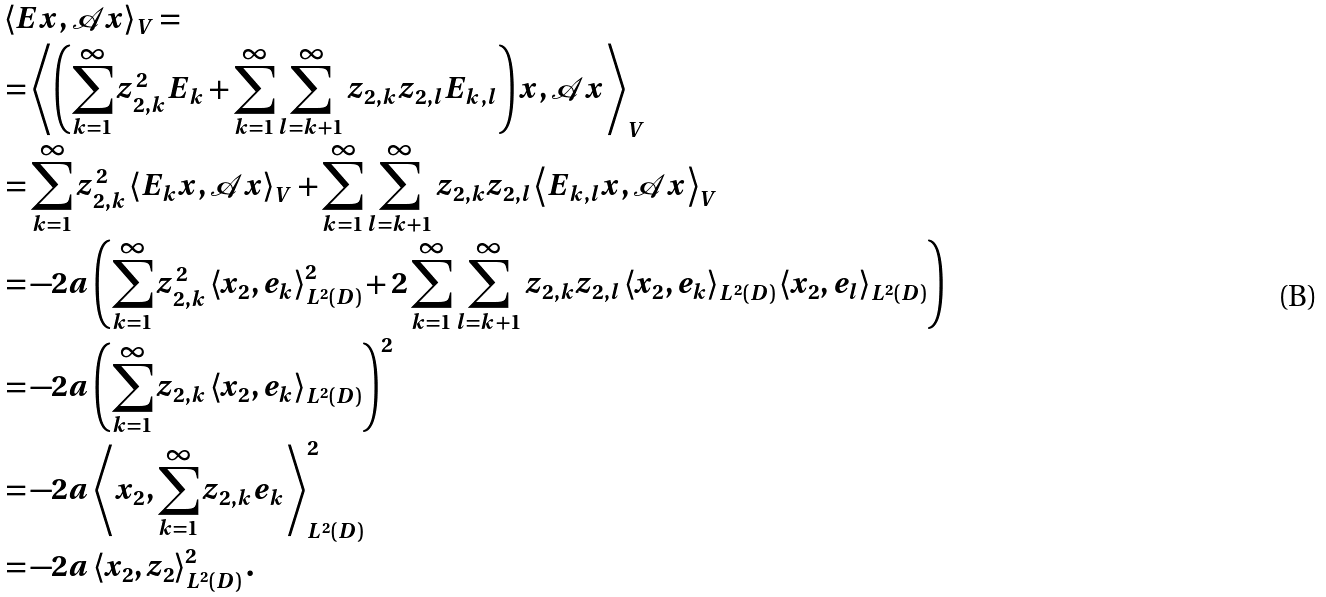<formula> <loc_0><loc_0><loc_500><loc_500>& \left \langle E x , \mathcal { A } x \right \rangle _ { V } = \\ & = \left \langle \left ( \sum _ { k = 1 } ^ { \infty } z _ { 2 , k } ^ { 2 } E _ { k } + \sum _ { k = 1 } ^ { \infty } \sum _ { l = k + 1 } ^ { \infty } z _ { 2 , k } z _ { 2 , l } E _ { k , l } \right ) x , \mathcal { A } x \right \rangle _ { V } \\ & = \sum _ { k = 1 } ^ { \infty } z _ { 2 , k } ^ { 2 } \left \langle E _ { k } x , \mathcal { A } x \right \rangle _ { V } + \sum _ { k = 1 } ^ { \infty } \sum _ { l = k + 1 } ^ { \infty } z _ { 2 , k } z _ { 2 , l } \left \langle E _ { k , l } x , \mathcal { A } x \right \rangle _ { V } \\ & = - 2 a \left ( \sum _ { k = 1 } ^ { \infty } z _ { 2 , k } ^ { 2 } \left \langle x _ { 2 } , e _ { k } \right \rangle _ { L ^ { 2 } ( D ) } ^ { 2 } + 2 \sum _ { k = 1 } ^ { \infty } \sum _ { l = k + 1 } ^ { \infty } z _ { 2 , k } z _ { 2 , l } \left \langle x _ { 2 } , e _ { k } \right \rangle _ { L ^ { 2 } ( D ) } \left \langle x _ { 2 } , e _ { l } \right \rangle _ { L ^ { 2 } ( D ) } \right ) \\ & = - 2 a \left ( \sum _ { k = 1 } ^ { \infty } z _ { 2 , k } \left \langle x _ { 2 } , e _ { k } \right \rangle _ { L ^ { 2 } ( D ) } \right ) ^ { 2 } \\ & = - 2 a \left \langle x _ { 2 } , \sum _ { k = 1 } ^ { \infty } z _ { 2 , k } e _ { k } \right \rangle _ { L ^ { 2 } ( D ) } ^ { 2 } \\ & = - 2 a \left \langle x _ { 2 } , z _ { 2 } \right \rangle _ { L ^ { 2 } ( D ) } ^ { 2 } .</formula> 